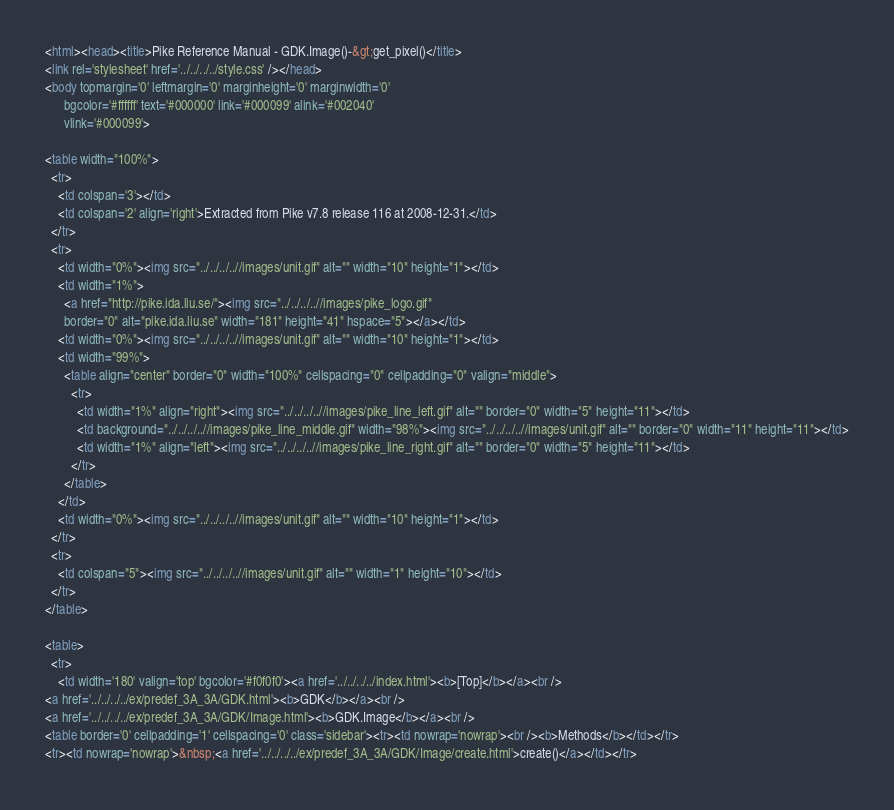Convert code to text. <code><loc_0><loc_0><loc_500><loc_500><_HTML_><html><head><title>Pike Reference Manual - GDK.Image()-&gt;get_pixel()</title>
<link rel='stylesheet' href='../../../../style.css' /></head>
<body topmargin='0' leftmargin='0' marginheight='0' marginwidth='0'
      bgcolor='#ffffff' text='#000000' link='#000099' alink='#002040'
      vlink='#000099'>

<table width="100%">
  <tr>
    <td colspan='3'></td>
    <td colspan='2' align='right'>Extracted from Pike v7.8 release 116 at 2008-12-31.</td>
  </tr>
  <tr>
    <td width="0%"><img src="../../../..//images/unit.gif" alt="" width="10" height="1"></td>
    <td width="1%">
      <a href="http://pike.ida.liu.se/"><img src="../../../..//images/pike_logo.gif"
      border="0" alt="pike.ida.liu.se" width="181" height="41" hspace="5"></a></td>
    <td width="0%"><img src="../../../..//images/unit.gif" alt="" width="10" height="1"></td>
    <td width="99%">
      <table align="center" border="0" width="100%" cellspacing="0" cellpadding="0" valign="middle">
        <tr>
          <td width="1%" align="right"><img src="../../../..//images/pike_line_left.gif" alt="" border="0" width="5" height="11"></td>
          <td background="../../../..//images/pike_line_middle.gif" width="98%"><img src="../../../..//images/unit.gif" alt="" border="0" width="11" height="11"></td>
          <td width="1%" align="left"><img src="../../../..//images/pike_line_right.gif" alt="" border="0" width="5" height="11"></td>
        </tr>
      </table>
    </td>
    <td width="0%"><img src="../../../..//images/unit.gif" alt="" width="10" height="1"></td>
  </tr>
  <tr>
    <td colspan="5"><img src="../../../..//images/unit.gif" alt="" width="1" height="10"></td>
  </tr>
</table>

<table>
  <tr>
    <td width='180' valign='top' bgcolor='#f0f0f0'><a href='../../../../index.html'><b>[Top]</b></a><br />
<a href='../../../../ex/predef_3A_3A/GDK.html'><b>GDK</b></a><br />
<a href='../../../../ex/predef_3A_3A/GDK/Image.html'><b>GDK.Image</b></a><br />
<table border='0' cellpadding='1' cellspacing='0' class='sidebar'><tr><td nowrap='nowrap'><br /><b>Methods</b></td></tr>
<tr><td nowrap='nowrap'>&nbsp;<a href='../../../../ex/predef_3A_3A/GDK/Image/create.html'>create()</a></td></tr></code> 